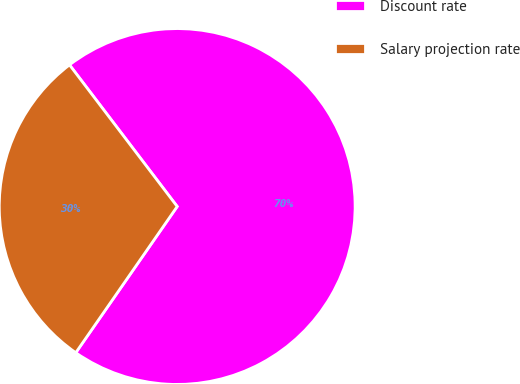Convert chart to OTSL. <chart><loc_0><loc_0><loc_500><loc_500><pie_chart><fcel>Discount rate<fcel>Salary projection rate<nl><fcel>70.0%<fcel>30.0%<nl></chart> 